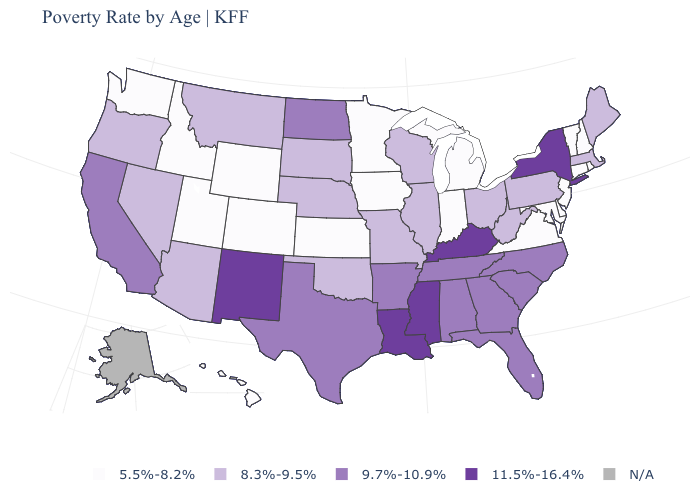What is the value of Delaware?
Give a very brief answer. 5.5%-8.2%. Is the legend a continuous bar?
Answer briefly. No. What is the value of Tennessee?
Write a very short answer. 9.7%-10.9%. Name the states that have a value in the range 5.5%-8.2%?
Concise answer only. Colorado, Connecticut, Delaware, Hawaii, Idaho, Indiana, Iowa, Kansas, Maryland, Michigan, Minnesota, New Hampshire, New Jersey, Rhode Island, Utah, Vermont, Virginia, Washington, Wyoming. Does Kansas have the lowest value in the MidWest?
Give a very brief answer. Yes. Which states have the highest value in the USA?
Answer briefly. Kentucky, Louisiana, Mississippi, New Mexico, New York. What is the lowest value in the West?
Write a very short answer. 5.5%-8.2%. Which states hav the highest value in the Northeast?
Keep it brief. New York. Which states have the lowest value in the South?
Give a very brief answer. Delaware, Maryland, Virginia. What is the lowest value in states that border New Mexico?
Give a very brief answer. 5.5%-8.2%. Which states hav the highest value in the Northeast?
Answer briefly. New York. What is the highest value in the MidWest ?
Short answer required. 9.7%-10.9%. Which states have the lowest value in the USA?
Keep it brief. Colorado, Connecticut, Delaware, Hawaii, Idaho, Indiana, Iowa, Kansas, Maryland, Michigan, Minnesota, New Hampshire, New Jersey, Rhode Island, Utah, Vermont, Virginia, Washington, Wyoming. 